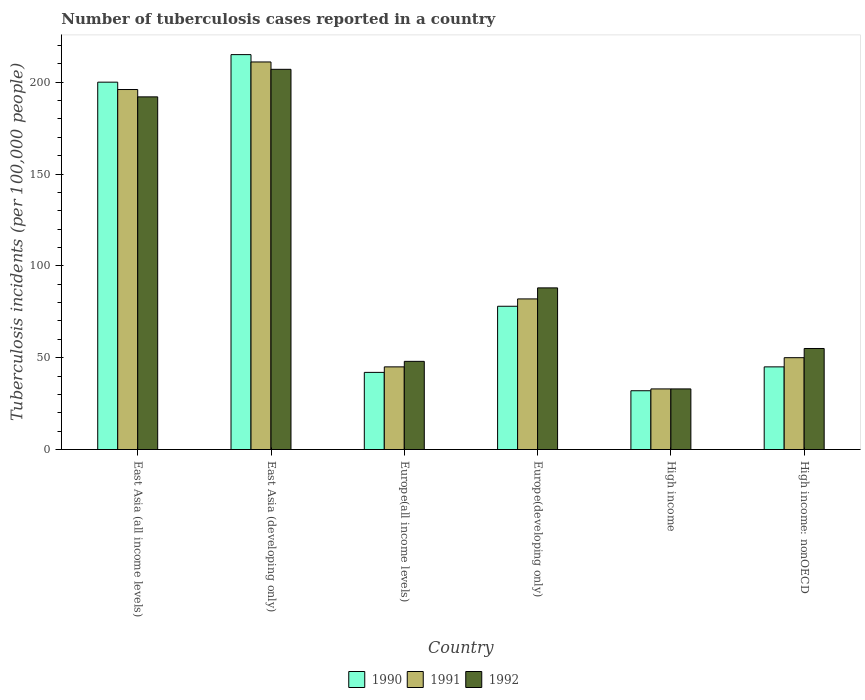How many groups of bars are there?
Provide a succinct answer. 6. Are the number of bars on each tick of the X-axis equal?
Provide a short and direct response. Yes. How many bars are there on the 1st tick from the left?
Your response must be concise. 3. How many bars are there on the 6th tick from the right?
Make the answer very short. 3. What is the label of the 6th group of bars from the left?
Provide a succinct answer. High income: nonOECD. What is the number of tuberculosis cases reported in in 1991 in East Asia (developing only)?
Keep it short and to the point. 211. Across all countries, what is the maximum number of tuberculosis cases reported in in 1991?
Offer a terse response. 211. Across all countries, what is the minimum number of tuberculosis cases reported in in 1991?
Ensure brevity in your answer.  33. In which country was the number of tuberculosis cases reported in in 1991 maximum?
Offer a terse response. East Asia (developing only). What is the total number of tuberculosis cases reported in in 1990 in the graph?
Make the answer very short. 612. What is the difference between the number of tuberculosis cases reported in in 1992 in East Asia (developing only) and that in High income: nonOECD?
Ensure brevity in your answer.  152. What is the average number of tuberculosis cases reported in in 1990 per country?
Give a very brief answer. 102. What is the ratio of the number of tuberculosis cases reported in in 1992 in Europe(all income levels) to that in Europe(developing only)?
Keep it short and to the point. 0.55. What is the difference between the highest and the second highest number of tuberculosis cases reported in in 1990?
Keep it short and to the point. 122. What is the difference between the highest and the lowest number of tuberculosis cases reported in in 1991?
Keep it short and to the point. 178. Is it the case that in every country, the sum of the number of tuberculosis cases reported in in 1991 and number of tuberculosis cases reported in in 1992 is greater than the number of tuberculosis cases reported in in 1990?
Your answer should be very brief. Yes. How many bars are there?
Provide a short and direct response. 18. Are all the bars in the graph horizontal?
Make the answer very short. No. How many countries are there in the graph?
Offer a terse response. 6. Does the graph contain any zero values?
Your answer should be compact. No. Where does the legend appear in the graph?
Your answer should be compact. Bottom center. How many legend labels are there?
Ensure brevity in your answer.  3. What is the title of the graph?
Keep it short and to the point. Number of tuberculosis cases reported in a country. Does "2008" appear as one of the legend labels in the graph?
Offer a very short reply. No. What is the label or title of the X-axis?
Your answer should be very brief. Country. What is the label or title of the Y-axis?
Make the answer very short. Tuberculosis incidents (per 100,0 people). What is the Tuberculosis incidents (per 100,000 people) of 1990 in East Asia (all income levels)?
Offer a terse response. 200. What is the Tuberculosis incidents (per 100,000 people) in 1991 in East Asia (all income levels)?
Offer a very short reply. 196. What is the Tuberculosis incidents (per 100,000 people) in 1992 in East Asia (all income levels)?
Keep it short and to the point. 192. What is the Tuberculosis incidents (per 100,000 people) in 1990 in East Asia (developing only)?
Ensure brevity in your answer.  215. What is the Tuberculosis incidents (per 100,000 people) of 1991 in East Asia (developing only)?
Provide a short and direct response. 211. What is the Tuberculosis incidents (per 100,000 people) of 1992 in East Asia (developing only)?
Ensure brevity in your answer.  207. What is the Tuberculosis incidents (per 100,000 people) in 1991 in Europe(all income levels)?
Make the answer very short. 45. What is the Tuberculosis incidents (per 100,000 people) of 1992 in High income?
Provide a short and direct response. 33. What is the Tuberculosis incidents (per 100,000 people) of 1990 in High income: nonOECD?
Your answer should be compact. 45. Across all countries, what is the maximum Tuberculosis incidents (per 100,000 people) in 1990?
Your answer should be very brief. 215. Across all countries, what is the maximum Tuberculosis incidents (per 100,000 people) of 1991?
Give a very brief answer. 211. Across all countries, what is the maximum Tuberculosis incidents (per 100,000 people) in 1992?
Provide a short and direct response. 207. Across all countries, what is the minimum Tuberculosis incidents (per 100,000 people) of 1990?
Offer a terse response. 32. Across all countries, what is the minimum Tuberculosis incidents (per 100,000 people) in 1991?
Provide a succinct answer. 33. Across all countries, what is the minimum Tuberculosis incidents (per 100,000 people) of 1992?
Keep it short and to the point. 33. What is the total Tuberculosis incidents (per 100,000 people) in 1990 in the graph?
Ensure brevity in your answer.  612. What is the total Tuberculosis incidents (per 100,000 people) in 1991 in the graph?
Offer a very short reply. 617. What is the total Tuberculosis incidents (per 100,000 people) of 1992 in the graph?
Your answer should be compact. 623. What is the difference between the Tuberculosis incidents (per 100,000 people) in 1990 in East Asia (all income levels) and that in East Asia (developing only)?
Provide a succinct answer. -15. What is the difference between the Tuberculosis incidents (per 100,000 people) in 1992 in East Asia (all income levels) and that in East Asia (developing only)?
Your answer should be very brief. -15. What is the difference between the Tuberculosis incidents (per 100,000 people) in 1990 in East Asia (all income levels) and that in Europe(all income levels)?
Offer a terse response. 158. What is the difference between the Tuberculosis incidents (per 100,000 people) of 1991 in East Asia (all income levels) and that in Europe(all income levels)?
Your answer should be very brief. 151. What is the difference between the Tuberculosis incidents (per 100,000 people) of 1992 in East Asia (all income levels) and that in Europe(all income levels)?
Make the answer very short. 144. What is the difference between the Tuberculosis incidents (per 100,000 people) in 1990 in East Asia (all income levels) and that in Europe(developing only)?
Provide a succinct answer. 122. What is the difference between the Tuberculosis incidents (per 100,000 people) in 1991 in East Asia (all income levels) and that in Europe(developing only)?
Your response must be concise. 114. What is the difference between the Tuberculosis incidents (per 100,000 people) in 1992 in East Asia (all income levels) and that in Europe(developing only)?
Offer a very short reply. 104. What is the difference between the Tuberculosis incidents (per 100,000 people) in 1990 in East Asia (all income levels) and that in High income?
Make the answer very short. 168. What is the difference between the Tuberculosis incidents (per 100,000 people) in 1991 in East Asia (all income levels) and that in High income?
Ensure brevity in your answer.  163. What is the difference between the Tuberculosis incidents (per 100,000 people) in 1992 in East Asia (all income levels) and that in High income?
Your answer should be compact. 159. What is the difference between the Tuberculosis incidents (per 100,000 people) of 1990 in East Asia (all income levels) and that in High income: nonOECD?
Give a very brief answer. 155. What is the difference between the Tuberculosis incidents (per 100,000 people) in 1991 in East Asia (all income levels) and that in High income: nonOECD?
Provide a succinct answer. 146. What is the difference between the Tuberculosis incidents (per 100,000 people) in 1992 in East Asia (all income levels) and that in High income: nonOECD?
Offer a terse response. 137. What is the difference between the Tuberculosis incidents (per 100,000 people) in 1990 in East Asia (developing only) and that in Europe(all income levels)?
Keep it short and to the point. 173. What is the difference between the Tuberculosis incidents (per 100,000 people) of 1991 in East Asia (developing only) and that in Europe(all income levels)?
Give a very brief answer. 166. What is the difference between the Tuberculosis incidents (per 100,000 people) in 1992 in East Asia (developing only) and that in Europe(all income levels)?
Your answer should be compact. 159. What is the difference between the Tuberculosis incidents (per 100,000 people) of 1990 in East Asia (developing only) and that in Europe(developing only)?
Make the answer very short. 137. What is the difference between the Tuberculosis incidents (per 100,000 people) of 1991 in East Asia (developing only) and that in Europe(developing only)?
Keep it short and to the point. 129. What is the difference between the Tuberculosis incidents (per 100,000 people) in 1992 in East Asia (developing only) and that in Europe(developing only)?
Your answer should be very brief. 119. What is the difference between the Tuberculosis incidents (per 100,000 people) of 1990 in East Asia (developing only) and that in High income?
Your response must be concise. 183. What is the difference between the Tuberculosis incidents (per 100,000 people) in 1991 in East Asia (developing only) and that in High income?
Keep it short and to the point. 178. What is the difference between the Tuberculosis incidents (per 100,000 people) of 1992 in East Asia (developing only) and that in High income?
Make the answer very short. 174. What is the difference between the Tuberculosis incidents (per 100,000 people) of 1990 in East Asia (developing only) and that in High income: nonOECD?
Offer a very short reply. 170. What is the difference between the Tuberculosis incidents (per 100,000 people) in 1991 in East Asia (developing only) and that in High income: nonOECD?
Provide a short and direct response. 161. What is the difference between the Tuberculosis incidents (per 100,000 people) of 1992 in East Asia (developing only) and that in High income: nonOECD?
Make the answer very short. 152. What is the difference between the Tuberculosis incidents (per 100,000 people) in 1990 in Europe(all income levels) and that in Europe(developing only)?
Ensure brevity in your answer.  -36. What is the difference between the Tuberculosis incidents (per 100,000 people) of 1991 in Europe(all income levels) and that in Europe(developing only)?
Make the answer very short. -37. What is the difference between the Tuberculosis incidents (per 100,000 people) of 1991 in Europe(all income levels) and that in High income?
Make the answer very short. 12. What is the difference between the Tuberculosis incidents (per 100,000 people) of 1991 in Europe(developing only) and that in High income?
Your answer should be very brief. 49. What is the difference between the Tuberculosis incidents (per 100,000 people) of 1991 in Europe(developing only) and that in High income: nonOECD?
Provide a short and direct response. 32. What is the difference between the Tuberculosis incidents (per 100,000 people) in 1990 in High income and that in High income: nonOECD?
Your answer should be very brief. -13. What is the difference between the Tuberculosis incidents (per 100,000 people) of 1991 in High income and that in High income: nonOECD?
Make the answer very short. -17. What is the difference between the Tuberculosis incidents (per 100,000 people) of 1990 in East Asia (all income levels) and the Tuberculosis incidents (per 100,000 people) of 1992 in East Asia (developing only)?
Provide a succinct answer. -7. What is the difference between the Tuberculosis incidents (per 100,000 people) in 1990 in East Asia (all income levels) and the Tuberculosis incidents (per 100,000 people) in 1991 in Europe(all income levels)?
Provide a short and direct response. 155. What is the difference between the Tuberculosis incidents (per 100,000 people) in 1990 in East Asia (all income levels) and the Tuberculosis incidents (per 100,000 people) in 1992 in Europe(all income levels)?
Make the answer very short. 152. What is the difference between the Tuberculosis incidents (per 100,000 people) of 1991 in East Asia (all income levels) and the Tuberculosis incidents (per 100,000 people) of 1992 in Europe(all income levels)?
Offer a terse response. 148. What is the difference between the Tuberculosis incidents (per 100,000 people) of 1990 in East Asia (all income levels) and the Tuberculosis incidents (per 100,000 people) of 1991 in Europe(developing only)?
Offer a terse response. 118. What is the difference between the Tuberculosis incidents (per 100,000 people) in 1990 in East Asia (all income levels) and the Tuberculosis incidents (per 100,000 people) in 1992 in Europe(developing only)?
Your answer should be compact. 112. What is the difference between the Tuberculosis incidents (per 100,000 people) of 1991 in East Asia (all income levels) and the Tuberculosis incidents (per 100,000 people) of 1992 in Europe(developing only)?
Give a very brief answer. 108. What is the difference between the Tuberculosis incidents (per 100,000 people) in 1990 in East Asia (all income levels) and the Tuberculosis incidents (per 100,000 people) in 1991 in High income?
Make the answer very short. 167. What is the difference between the Tuberculosis incidents (per 100,000 people) of 1990 in East Asia (all income levels) and the Tuberculosis incidents (per 100,000 people) of 1992 in High income?
Give a very brief answer. 167. What is the difference between the Tuberculosis incidents (per 100,000 people) of 1991 in East Asia (all income levels) and the Tuberculosis incidents (per 100,000 people) of 1992 in High income?
Keep it short and to the point. 163. What is the difference between the Tuberculosis incidents (per 100,000 people) of 1990 in East Asia (all income levels) and the Tuberculosis incidents (per 100,000 people) of 1991 in High income: nonOECD?
Provide a short and direct response. 150. What is the difference between the Tuberculosis incidents (per 100,000 people) in 1990 in East Asia (all income levels) and the Tuberculosis incidents (per 100,000 people) in 1992 in High income: nonOECD?
Your response must be concise. 145. What is the difference between the Tuberculosis incidents (per 100,000 people) in 1991 in East Asia (all income levels) and the Tuberculosis incidents (per 100,000 people) in 1992 in High income: nonOECD?
Make the answer very short. 141. What is the difference between the Tuberculosis incidents (per 100,000 people) in 1990 in East Asia (developing only) and the Tuberculosis incidents (per 100,000 people) in 1991 in Europe(all income levels)?
Offer a very short reply. 170. What is the difference between the Tuberculosis incidents (per 100,000 people) of 1990 in East Asia (developing only) and the Tuberculosis incidents (per 100,000 people) of 1992 in Europe(all income levels)?
Your answer should be very brief. 167. What is the difference between the Tuberculosis incidents (per 100,000 people) of 1991 in East Asia (developing only) and the Tuberculosis incidents (per 100,000 people) of 1992 in Europe(all income levels)?
Ensure brevity in your answer.  163. What is the difference between the Tuberculosis incidents (per 100,000 people) of 1990 in East Asia (developing only) and the Tuberculosis incidents (per 100,000 people) of 1991 in Europe(developing only)?
Ensure brevity in your answer.  133. What is the difference between the Tuberculosis incidents (per 100,000 people) in 1990 in East Asia (developing only) and the Tuberculosis incidents (per 100,000 people) in 1992 in Europe(developing only)?
Ensure brevity in your answer.  127. What is the difference between the Tuberculosis incidents (per 100,000 people) in 1991 in East Asia (developing only) and the Tuberculosis incidents (per 100,000 people) in 1992 in Europe(developing only)?
Ensure brevity in your answer.  123. What is the difference between the Tuberculosis incidents (per 100,000 people) of 1990 in East Asia (developing only) and the Tuberculosis incidents (per 100,000 people) of 1991 in High income?
Provide a succinct answer. 182. What is the difference between the Tuberculosis incidents (per 100,000 people) in 1990 in East Asia (developing only) and the Tuberculosis incidents (per 100,000 people) in 1992 in High income?
Your response must be concise. 182. What is the difference between the Tuberculosis incidents (per 100,000 people) of 1991 in East Asia (developing only) and the Tuberculosis incidents (per 100,000 people) of 1992 in High income?
Offer a terse response. 178. What is the difference between the Tuberculosis incidents (per 100,000 people) in 1990 in East Asia (developing only) and the Tuberculosis incidents (per 100,000 people) in 1991 in High income: nonOECD?
Keep it short and to the point. 165. What is the difference between the Tuberculosis incidents (per 100,000 people) in 1990 in East Asia (developing only) and the Tuberculosis incidents (per 100,000 people) in 1992 in High income: nonOECD?
Your answer should be compact. 160. What is the difference between the Tuberculosis incidents (per 100,000 people) of 1991 in East Asia (developing only) and the Tuberculosis incidents (per 100,000 people) of 1992 in High income: nonOECD?
Offer a very short reply. 156. What is the difference between the Tuberculosis incidents (per 100,000 people) in 1990 in Europe(all income levels) and the Tuberculosis incidents (per 100,000 people) in 1992 in Europe(developing only)?
Offer a terse response. -46. What is the difference between the Tuberculosis incidents (per 100,000 people) in 1991 in Europe(all income levels) and the Tuberculosis incidents (per 100,000 people) in 1992 in Europe(developing only)?
Offer a terse response. -43. What is the difference between the Tuberculosis incidents (per 100,000 people) in 1990 in Europe(all income levels) and the Tuberculosis incidents (per 100,000 people) in 1992 in High income?
Offer a very short reply. 9. What is the difference between the Tuberculosis incidents (per 100,000 people) in 1990 in Europe(all income levels) and the Tuberculosis incidents (per 100,000 people) in 1992 in High income: nonOECD?
Your response must be concise. -13. What is the difference between the Tuberculosis incidents (per 100,000 people) of 1991 in Europe(all income levels) and the Tuberculosis incidents (per 100,000 people) of 1992 in High income: nonOECD?
Provide a succinct answer. -10. What is the difference between the Tuberculosis incidents (per 100,000 people) in 1990 in Europe(developing only) and the Tuberculosis incidents (per 100,000 people) in 1992 in High income?
Provide a short and direct response. 45. What is the difference between the Tuberculosis incidents (per 100,000 people) of 1991 in Europe(developing only) and the Tuberculosis incidents (per 100,000 people) of 1992 in High income?
Provide a short and direct response. 49. What is the difference between the Tuberculosis incidents (per 100,000 people) in 1990 in Europe(developing only) and the Tuberculosis incidents (per 100,000 people) in 1991 in High income: nonOECD?
Ensure brevity in your answer.  28. What is the difference between the Tuberculosis incidents (per 100,000 people) of 1991 in Europe(developing only) and the Tuberculosis incidents (per 100,000 people) of 1992 in High income: nonOECD?
Your response must be concise. 27. What is the difference between the Tuberculosis incidents (per 100,000 people) of 1990 in High income and the Tuberculosis incidents (per 100,000 people) of 1991 in High income: nonOECD?
Offer a terse response. -18. What is the average Tuberculosis incidents (per 100,000 people) in 1990 per country?
Give a very brief answer. 102. What is the average Tuberculosis incidents (per 100,000 people) of 1991 per country?
Give a very brief answer. 102.83. What is the average Tuberculosis incidents (per 100,000 people) of 1992 per country?
Give a very brief answer. 103.83. What is the difference between the Tuberculosis incidents (per 100,000 people) in 1991 and Tuberculosis incidents (per 100,000 people) in 1992 in East Asia (all income levels)?
Keep it short and to the point. 4. What is the difference between the Tuberculosis incidents (per 100,000 people) in 1991 and Tuberculosis incidents (per 100,000 people) in 1992 in East Asia (developing only)?
Your answer should be compact. 4. What is the difference between the Tuberculosis incidents (per 100,000 people) of 1990 and Tuberculosis incidents (per 100,000 people) of 1991 in Europe(developing only)?
Make the answer very short. -4. What is the difference between the Tuberculosis incidents (per 100,000 people) of 1990 and Tuberculosis incidents (per 100,000 people) of 1992 in Europe(developing only)?
Give a very brief answer. -10. What is the difference between the Tuberculosis incidents (per 100,000 people) of 1990 and Tuberculosis incidents (per 100,000 people) of 1991 in High income?
Make the answer very short. -1. What is the difference between the Tuberculosis incidents (per 100,000 people) in 1990 and Tuberculosis incidents (per 100,000 people) in 1992 in High income?
Make the answer very short. -1. What is the difference between the Tuberculosis incidents (per 100,000 people) of 1991 and Tuberculosis incidents (per 100,000 people) of 1992 in High income?
Your answer should be compact. 0. What is the difference between the Tuberculosis incidents (per 100,000 people) of 1991 and Tuberculosis incidents (per 100,000 people) of 1992 in High income: nonOECD?
Your answer should be very brief. -5. What is the ratio of the Tuberculosis incidents (per 100,000 people) of 1990 in East Asia (all income levels) to that in East Asia (developing only)?
Give a very brief answer. 0.93. What is the ratio of the Tuberculosis incidents (per 100,000 people) in 1991 in East Asia (all income levels) to that in East Asia (developing only)?
Provide a succinct answer. 0.93. What is the ratio of the Tuberculosis incidents (per 100,000 people) of 1992 in East Asia (all income levels) to that in East Asia (developing only)?
Provide a succinct answer. 0.93. What is the ratio of the Tuberculosis incidents (per 100,000 people) of 1990 in East Asia (all income levels) to that in Europe(all income levels)?
Your response must be concise. 4.76. What is the ratio of the Tuberculosis incidents (per 100,000 people) in 1991 in East Asia (all income levels) to that in Europe(all income levels)?
Offer a very short reply. 4.36. What is the ratio of the Tuberculosis incidents (per 100,000 people) in 1992 in East Asia (all income levels) to that in Europe(all income levels)?
Offer a terse response. 4. What is the ratio of the Tuberculosis incidents (per 100,000 people) of 1990 in East Asia (all income levels) to that in Europe(developing only)?
Keep it short and to the point. 2.56. What is the ratio of the Tuberculosis incidents (per 100,000 people) in 1991 in East Asia (all income levels) to that in Europe(developing only)?
Give a very brief answer. 2.39. What is the ratio of the Tuberculosis incidents (per 100,000 people) in 1992 in East Asia (all income levels) to that in Europe(developing only)?
Make the answer very short. 2.18. What is the ratio of the Tuberculosis incidents (per 100,000 people) of 1990 in East Asia (all income levels) to that in High income?
Give a very brief answer. 6.25. What is the ratio of the Tuberculosis incidents (per 100,000 people) in 1991 in East Asia (all income levels) to that in High income?
Your answer should be very brief. 5.94. What is the ratio of the Tuberculosis incidents (per 100,000 people) of 1992 in East Asia (all income levels) to that in High income?
Offer a very short reply. 5.82. What is the ratio of the Tuberculosis incidents (per 100,000 people) of 1990 in East Asia (all income levels) to that in High income: nonOECD?
Keep it short and to the point. 4.44. What is the ratio of the Tuberculosis incidents (per 100,000 people) in 1991 in East Asia (all income levels) to that in High income: nonOECD?
Give a very brief answer. 3.92. What is the ratio of the Tuberculosis incidents (per 100,000 people) in 1992 in East Asia (all income levels) to that in High income: nonOECD?
Offer a very short reply. 3.49. What is the ratio of the Tuberculosis incidents (per 100,000 people) of 1990 in East Asia (developing only) to that in Europe(all income levels)?
Make the answer very short. 5.12. What is the ratio of the Tuberculosis incidents (per 100,000 people) of 1991 in East Asia (developing only) to that in Europe(all income levels)?
Ensure brevity in your answer.  4.69. What is the ratio of the Tuberculosis incidents (per 100,000 people) of 1992 in East Asia (developing only) to that in Europe(all income levels)?
Your answer should be very brief. 4.31. What is the ratio of the Tuberculosis incidents (per 100,000 people) of 1990 in East Asia (developing only) to that in Europe(developing only)?
Provide a succinct answer. 2.76. What is the ratio of the Tuberculosis incidents (per 100,000 people) in 1991 in East Asia (developing only) to that in Europe(developing only)?
Offer a very short reply. 2.57. What is the ratio of the Tuberculosis incidents (per 100,000 people) of 1992 in East Asia (developing only) to that in Europe(developing only)?
Your answer should be very brief. 2.35. What is the ratio of the Tuberculosis incidents (per 100,000 people) in 1990 in East Asia (developing only) to that in High income?
Provide a short and direct response. 6.72. What is the ratio of the Tuberculosis incidents (per 100,000 people) of 1991 in East Asia (developing only) to that in High income?
Provide a succinct answer. 6.39. What is the ratio of the Tuberculosis incidents (per 100,000 people) of 1992 in East Asia (developing only) to that in High income?
Provide a short and direct response. 6.27. What is the ratio of the Tuberculosis incidents (per 100,000 people) of 1990 in East Asia (developing only) to that in High income: nonOECD?
Your answer should be compact. 4.78. What is the ratio of the Tuberculosis incidents (per 100,000 people) in 1991 in East Asia (developing only) to that in High income: nonOECD?
Your answer should be compact. 4.22. What is the ratio of the Tuberculosis incidents (per 100,000 people) in 1992 in East Asia (developing only) to that in High income: nonOECD?
Your answer should be very brief. 3.76. What is the ratio of the Tuberculosis incidents (per 100,000 people) of 1990 in Europe(all income levels) to that in Europe(developing only)?
Give a very brief answer. 0.54. What is the ratio of the Tuberculosis incidents (per 100,000 people) in 1991 in Europe(all income levels) to that in Europe(developing only)?
Give a very brief answer. 0.55. What is the ratio of the Tuberculosis incidents (per 100,000 people) of 1992 in Europe(all income levels) to that in Europe(developing only)?
Offer a very short reply. 0.55. What is the ratio of the Tuberculosis incidents (per 100,000 people) in 1990 in Europe(all income levels) to that in High income?
Make the answer very short. 1.31. What is the ratio of the Tuberculosis incidents (per 100,000 people) in 1991 in Europe(all income levels) to that in High income?
Offer a very short reply. 1.36. What is the ratio of the Tuberculosis incidents (per 100,000 people) in 1992 in Europe(all income levels) to that in High income?
Your response must be concise. 1.45. What is the ratio of the Tuberculosis incidents (per 100,000 people) of 1991 in Europe(all income levels) to that in High income: nonOECD?
Provide a short and direct response. 0.9. What is the ratio of the Tuberculosis incidents (per 100,000 people) in 1992 in Europe(all income levels) to that in High income: nonOECD?
Offer a terse response. 0.87. What is the ratio of the Tuberculosis incidents (per 100,000 people) of 1990 in Europe(developing only) to that in High income?
Your response must be concise. 2.44. What is the ratio of the Tuberculosis incidents (per 100,000 people) of 1991 in Europe(developing only) to that in High income?
Make the answer very short. 2.48. What is the ratio of the Tuberculosis incidents (per 100,000 people) in 1992 in Europe(developing only) to that in High income?
Keep it short and to the point. 2.67. What is the ratio of the Tuberculosis incidents (per 100,000 people) of 1990 in Europe(developing only) to that in High income: nonOECD?
Provide a succinct answer. 1.73. What is the ratio of the Tuberculosis incidents (per 100,000 people) in 1991 in Europe(developing only) to that in High income: nonOECD?
Your answer should be compact. 1.64. What is the ratio of the Tuberculosis incidents (per 100,000 people) of 1992 in Europe(developing only) to that in High income: nonOECD?
Ensure brevity in your answer.  1.6. What is the ratio of the Tuberculosis incidents (per 100,000 people) in 1990 in High income to that in High income: nonOECD?
Make the answer very short. 0.71. What is the ratio of the Tuberculosis incidents (per 100,000 people) in 1991 in High income to that in High income: nonOECD?
Your response must be concise. 0.66. What is the difference between the highest and the second highest Tuberculosis incidents (per 100,000 people) of 1991?
Your answer should be compact. 15. What is the difference between the highest and the lowest Tuberculosis incidents (per 100,000 people) in 1990?
Your answer should be very brief. 183. What is the difference between the highest and the lowest Tuberculosis incidents (per 100,000 people) in 1991?
Your response must be concise. 178. What is the difference between the highest and the lowest Tuberculosis incidents (per 100,000 people) of 1992?
Ensure brevity in your answer.  174. 